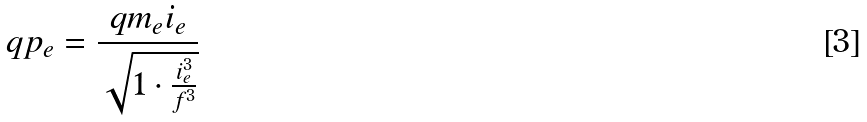Convert formula to latex. <formula><loc_0><loc_0><loc_500><loc_500>q p _ { e } = \frac { q m _ { e } i _ { e } } { \sqrt { 1 \cdot \frac { i _ { e } ^ { 3 } } { f ^ { 3 } } } }</formula> 